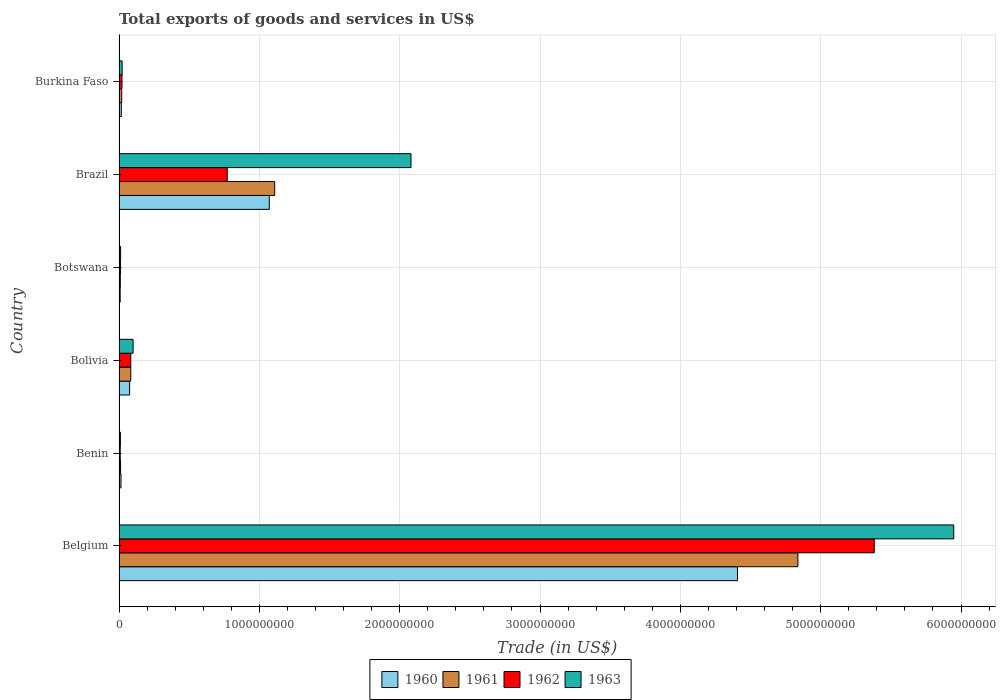Are the number of bars on each tick of the Y-axis equal?
Ensure brevity in your answer.  Yes. How many bars are there on the 1st tick from the bottom?
Your answer should be compact. 4. In how many cases, is the number of bars for a given country not equal to the number of legend labels?
Provide a short and direct response. 0. What is the total exports of goods and services in 1962 in Bolivia?
Offer a terse response. 8.35e+07. Across all countries, what is the maximum total exports of goods and services in 1962?
Offer a terse response. 5.38e+09. Across all countries, what is the minimum total exports of goods and services in 1961?
Keep it short and to the point. 8.95e+06. In which country was the total exports of goods and services in 1961 minimum?
Ensure brevity in your answer.  Botswana. What is the total total exports of goods and services in 1961 in the graph?
Your answer should be compact. 6.07e+09. What is the difference between the total exports of goods and services in 1963 in Botswana and that in Burkina Faso?
Your response must be concise. -1.09e+07. What is the difference between the total exports of goods and services in 1963 in Bolivia and the total exports of goods and services in 1960 in Benin?
Your answer should be compact. 8.63e+07. What is the average total exports of goods and services in 1961 per country?
Provide a short and direct response. 1.01e+09. What is the difference between the total exports of goods and services in 1963 and total exports of goods and services in 1961 in Burkina Faso?
Provide a succinct answer. 2.97e+06. In how many countries, is the total exports of goods and services in 1963 greater than 3800000000 US$?
Your response must be concise. 1. What is the ratio of the total exports of goods and services in 1963 in Benin to that in Botswana?
Offer a very short reply. 0.88. Is the total exports of goods and services in 1963 in Benin less than that in Bolivia?
Your response must be concise. Yes. Is the difference between the total exports of goods and services in 1963 in Benin and Botswana greater than the difference between the total exports of goods and services in 1961 in Benin and Botswana?
Ensure brevity in your answer.  No. What is the difference between the highest and the second highest total exports of goods and services in 1962?
Ensure brevity in your answer.  4.61e+09. What is the difference between the highest and the lowest total exports of goods and services in 1960?
Your answer should be very brief. 4.40e+09. In how many countries, is the total exports of goods and services in 1960 greater than the average total exports of goods and services in 1960 taken over all countries?
Provide a short and direct response. 2. Is it the case that in every country, the sum of the total exports of goods and services in 1960 and total exports of goods and services in 1961 is greater than the sum of total exports of goods and services in 1962 and total exports of goods and services in 1963?
Provide a short and direct response. No. What does the 3rd bar from the bottom in Brazil represents?
Make the answer very short. 1962. How many bars are there?
Your answer should be compact. 24. Are the values on the major ticks of X-axis written in scientific E-notation?
Provide a short and direct response. No. How are the legend labels stacked?
Ensure brevity in your answer.  Horizontal. What is the title of the graph?
Provide a short and direct response. Total exports of goods and services in US$. What is the label or title of the X-axis?
Offer a very short reply. Trade (in US$). What is the label or title of the Y-axis?
Ensure brevity in your answer.  Country. What is the Trade (in US$) in 1960 in Belgium?
Your response must be concise. 4.41e+09. What is the Trade (in US$) of 1961 in Belgium?
Offer a terse response. 4.84e+09. What is the Trade (in US$) in 1962 in Belgium?
Make the answer very short. 5.38e+09. What is the Trade (in US$) in 1963 in Belgium?
Offer a terse response. 5.95e+09. What is the Trade (in US$) of 1960 in Benin?
Your answer should be very brief. 1.39e+07. What is the Trade (in US$) in 1961 in Benin?
Your answer should be compact. 1.08e+07. What is the Trade (in US$) in 1962 in Benin?
Give a very brief answer. 8.32e+06. What is the Trade (in US$) of 1963 in Benin?
Keep it short and to the point. 9.70e+06. What is the Trade (in US$) of 1960 in Bolivia?
Your answer should be very brief. 7.51e+07. What is the Trade (in US$) of 1961 in Bolivia?
Make the answer very short. 8.35e+07. What is the Trade (in US$) of 1962 in Bolivia?
Your response must be concise. 8.35e+07. What is the Trade (in US$) in 1963 in Bolivia?
Offer a very short reply. 1.00e+08. What is the Trade (in US$) of 1960 in Botswana?
Offer a very short reply. 7.99e+06. What is the Trade (in US$) in 1961 in Botswana?
Your answer should be very brief. 8.95e+06. What is the Trade (in US$) of 1962 in Botswana?
Keep it short and to the point. 9.95e+06. What is the Trade (in US$) of 1963 in Botswana?
Your answer should be compact. 1.10e+07. What is the Trade (in US$) of 1960 in Brazil?
Give a very brief answer. 1.07e+09. What is the Trade (in US$) of 1961 in Brazil?
Provide a short and direct response. 1.11e+09. What is the Trade (in US$) in 1962 in Brazil?
Offer a terse response. 7.71e+08. What is the Trade (in US$) of 1963 in Brazil?
Provide a succinct answer. 2.08e+09. What is the Trade (in US$) in 1960 in Burkina Faso?
Keep it short and to the point. 1.61e+07. What is the Trade (in US$) in 1961 in Burkina Faso?
Make the answer very short. 1.90e+07. What is the Trade (in US$) in 1962 in Burkina Faso?
Make the answer very short. 2.10e+07. What is the Trade (in US$) in 1963 in Burkina Faso?
Keep it short and to the point. 2.20e+07. Across all countries, what is the maximum Trade (in US$) of 1960?
Your response must be concise. 4.41e+09. Across all countries, what is the maximum Trade (in US$) of 1961?
Give a very brief answer. 4.84e+09. Across all countries, what is the maximum Trade (in US$) of 1962?
Offer a terse response. 5.38e+09. Across all countries, what is the maximum Trade (in US$) of 1963?
Give a very brief answer. 5.95e+09. Across all countries, what is the minimum Trade (in US$) of 1960?
Offer a very short reply. 7.99e+06. Across all countries, what is the minimum Trade (in US$) of 1961?
Offer a very short reply. 8.95e+06. Across all countries, what is the minimum Trade (in US$) of 1962?
Keep it short and to the point. 8.32e+06. Across all countries, what is the minimum Trade (in US$) of 1963?
Your answer should be compact. 9.70e+06. What is the total Trade (in US$) of 1960 in the graph?
Provide a short and direct response. 5.59e+09. What is the total Trade (in US$) of 1961 in the graph?
Ensure brevity in your answer.  6.07e+09. What is the total Trade (in US$) in 1962 in the graph?
Make the answer very short. 6.28e+09. What is the total Trade (in US$) in 1963 in the graph?
Ensure brevity in your answer.  8.17e+09. What is the difference between the Trade (in US$) of 1960 in Belgium and that in Benin?
Provide a succinct answer. 4.39e+09. What is the difference between the Trade (in US$) of 1961 in Belgium and that in Benin?
Your answer should be compact. 4.83e+09. What is the difference between the Trade (in US$) in 1962 in Belgium and that in Benin?
Offer a very short reply. 5.37e+09. What is the difference between the Trade (in US$) of 1963 in Belgium and that in Benin?
Provide a succinct answer. 5.94e+09. What is the difference between the Trade (in US$) of 1960 in Belgium and that in Bolivia?
Make the answer very short. 4.33e+09. What is the difference between the Trade (in US$) in 1961 in Belgium and that in Bolivia?
Offer a very short reply. 4.75e+09. What is the difference between the Trade (in US$) of 1962 in Belgium and that in Bolivia?
Provide a succinct answer. 5.30e+09. What is the difference between the Trade (in US$) in 1963 in Belgium and that in Bolivia?
Offer a very short reply. 5.85e+09. What is the difference between the Trade (in US$) in 1960 in Belgium and that in Botswana?
Keep it short and to the point. 4.40e+09. What is the difference between the Trade (in US$) of 1961 in Belgium and that in Botswana?
Offer a very short reply. 4.83e+09. What is the difference between the Trade (in US$) of 1962 in Belgium and that in Botswana?
Keep it short and to the point. 5.37e+09. What is the difference between the Trade (in US$) in 1963 in Belgium and that in Botswana?
Provide a succinct answer. 5.94e+09. What is the difference between the Trade (in US$) of 1960 in Belgium and that in Brazil?
Offer a very short reply. 3.34e+09. What is the difference between the Trade (in US$) in 1961 in Belgium and that in Brazil?
Provide a succinct answer. 3.73e+09. What is the difference between the Trade (in US$) in 1962 in Belgium and that in Brazil?
Ensure brevity in your answer.  4.61e+09. What is the difference between the Trade (in US$) of 1963 in Belgium and that in Brazil?
Ensure brevity in your answer.  3.87e+09. What is the difference between the Trade (in US$) of 1960 in Belgium and that in Burkina Faso?
Make the answer very short. 4.39e+09. What is the difference between the Trade (in US$) of 1961 in Belgium and that in Burkina Faso?
Provide a succinct answer. 4.82e+09. What is the difference between the Trade (in US$) of 1962 in Belgium and that in Burkina Faso?
Offer a very short reply. 5.36e+09. What is the difference between the Trade (in US$) of 1963 in Belgium and that in Burkina Faso?
Your answer should be very brief. 5.93e+09. What is the difference between the Trade (in US$) in 1960 in Benin and that in Bolivia?
Your response must be concise. -6.13e+07. What is the difference between the Trade (in US$) in 1961 in Benin and that in Bolivia?
Offer a very short reply. -7.27e+07. What is the difference between the Trade (in US$) in 1962 in Benin and that in Bolivia?
Your answer should be compact. -7.52e+07. What is the difference between the Trade (in US$) of 1963 in Benin and that in Bolivia?
Offer a very short reply. -9.05e+07. What is the difference between the Trade (in US$) of 1960 in Benin and that in Botswana?
Make the answer very short. 5.86e+06. What is the difference between the Trade (in US$) in 1961 in Benin and that in Botswana?
Your answer should be compact. 1.85e+06. What is the difference between the Trade (in US$) in 1962 in Benin and that in Botswana?
Make the answer very short. -1.64e+06. What is the difference between the Trade (in US$) of 1963 in Benin and that in Botswana?
Your answer should be very brief. -1.34e+06. What is the difference between the Trade (in US$) of 1960 in Benin and that in Brazil?
Make the answer very short. -1.06e+09. What is the difference between the Trade (in US$) of 1961 in Benin and that in Brazil?
Give a very brief answer. -1.10e+09. What is the difference between the Trade (in US$) in 1962 in Benin and that in Brazil?
Your response must be concise. -7.63e+08. What is the difference between the Trade (in US$) in 1963 in Benin and that in Brazil?
Give a very brief answer. -2.07e+09. What is the difference between the Trade (in US$) of 1960 in Benin and that in Burkina Faso?
Keep it short and to the point. -2.21e+06. What is the difference between the Trade (in US$) in 1961 in Benin and that in Burkina Faso?
Provide a succinct answer. -8.21e+06. What is the difference between the Trade (in US$) in 1962 in Benin and that in Burkina Faso?
Make the answer very short. -1.27e+07. What is the difference between the Trade (in US$) of 1963 in Benin and that in Burkina Faso?
Your answer should be compact. -1.23e+07. What is the difference between the Trade (in US$) of 1960 in Bolivia and that in Botswana?
Provide a succinct answer. 6.71e+07. What is the difference between the Trade (in US$) of 1961 in Bolivia and that in Botswana?
Your answer should be very brief. 7.45e+07. What is the difference between the Trade (in US$) of 1962 in Bolivia and that in Botswana?
Provide a succinct answer. 7.35e+07. What is the difference between the Trade (in US$) of 1963 in Bolivia and that in Botswana?
Provide a short and direct response. 8.91e+07. What is the difference between the Trade (in US$) in 1960 in Bolivia and that in Brazil?
Give a very brief answer. -9.95e+08. What is the difference between the Trade (in US$) of 1961 in Bolivia and that in Brazil?
Your response must be concise. -1.03e+09. What is the difference between the Trade (in US$) of 1962 in Bolivia and that in Brazil?
Your response must be concise. -6.87e+08. What is the difference between the Trade (in US$) in 1963 in Bolivia and that in Brazil?
Your answer should be very brief. -1.98e+09. What is the difference between the Trade (in US$) of 1960 in Bolivia and that in Burkina Faso?
Provide a succinct answer. 5.91e+07. What is the difference between the Trade (in US$) of 1961 in Bolivia and that in Burkina Faso?
Provide a short and direct response. 6.45e+07. What is the difference between the Trade (in US$) in 1962 in Bolivia and that in Burkina Faso?
Provide a succinct answer. 6.25e+07. What is the difference between the Trade (in US$) of 1963 in Bolivia and that in Burkina Faso?
Your answer should be compact. 7.82e+07. What is the difference between the Trade (in US$) in 1960 in Botswana and that in Brazil?
Offer a terse response. -1.06e+09. What is the difference between the Trade (in US$) in 1961 in Botswana and that in Brazil?
Provide a short and direct response. -1.10e+09. What is the difference between the Trade (in US$) of 1962 in Botswana and that in Brazil?
Provide a succinct answer. -7.61e+08. What is the difference between the Trade (in US$) of 1963 in Botswana and that in Brazil?
Keep it short and to the point. -2.07e+09. What is the difference between the Trade (in US$) of 1960 in Botswana and that in Burkina Faso?
Offer a terse response. -8.08e+06. What is the difference between the Trade (in US$) in 1961 in Botswana and that in Burkina Faso?
Your response must be concise. -1.01e+07. What is the difference between the Trade (in US$) of 1962 in Botswana and that in Burkina Faso?
Offer a terse response. -1.10e+07. What is the difference between the Trade (in US$) of 1963 in Botswana and that in Burkina Faso?
Give a very brief answer. -1.09e+07. What is the difference between the Trade (in US$) in 1960 in Brazil and that in Burkina Faso?
Keep it short and to the point. 1.05e+09. What is the difference between the Trade (in US$) of 1961 in Brazil and that in Burkina Faso?
Provide a short and direct response. 1.09e+09. What is the difference between the Trade (in US$) of 1962 in Brazil and that in Burkina Faso?
Make the answer very short. 7.50e+08. What is the difference between the Trade (in US$) in 1963 in Brazil and that in Burkina Faso?
Your answer should be compact. 2.06e+09. What is the difference between the Trade (in US$) in 1960 in Belgium and the Trade (in US$) in 1961 in Benin?
Offer a terse response. 4.40e+09. What is the difference between the Trade (in US$) in 1960 in Belgium and the Trade (in US$) in 1962 in Benin?
Offer a terse response. 4.40e+09. What is the difference between the Trade (in US$) in 1960 in Belgium and the Trade (in US$) in 1963 in Benin?
Offer a very short reply. 4.40e+09. What is the difference between the Trade (in US$) of 1961 in Belgium and the Trade (in US$) of 1962 in Benin?
Offer a very short reply. 4.83e+09. What is the difference between the Trade (in US$) in 1961 in Belgium and the Trade (in US$) in 1963 in Benin?
Your answer should be very brief. 4.83e+09. What is the difference between the Trade (in US$) in 1962 in Belgium and the Trade (in US$) in 1963 in Benin?
Offer a very short reply. 5.37e+09. What is the difference between the Trade (in US$) of 1960 in Belgium and the Trade (in US$) of 1961 in Bolivia?
Make the answer very short. 4.32e+09. What is the difference between the Trade (in US$) in 1960 in Belgium and the Trade (in US$) in 1962 in Bolivia?
Your answer should be very brief. 4.32e+09. What is the difference between the Trade (in US$) in 1960 in Belgium and the Trade (in US$) in 1963 in Bolivia?
Your response must be concise. 4.31e+09. What is the difference between the Trade (in US$) in 1961 in Belgium and the Trade (in US$) in 1962 in Bolivia?
Make the answer very short. 4.75e+09. What is the difference between the Trade (in US$) of 1961 in Belgium and the Trade (in US$) of 1963 in Bolivia?
Provide a succinct answer. 4.74e+09. What is the difference between the Trade (in US$) of 1962 in Belgium and the Trade (in US$) of 1963 in Bolivia?
Offer a terse response. 5.28e+09. What is the difference between the Trade (in US$) in 1960 in Belgium and the Trade (in US$) in 1961 in Botswana?
Your answer should be compact. 4.40e+09. What is the difference between the Trade (in US$) of 1960 in Belgium and the Trade (in US$) of 1962 in Botswana?
Keep it short and to the point. 4.40e+09. What is the difference between the Trade (in US$) of 1960 in Belgium and the Trade (in US$) of 1963 in Botswana?
Offer a very short reply. 4.40e+09. What is the difference between the Trade (in US$) of 1961 in Belgium and the Trade (in US$) of 1962 in Botswana?
Your response must be concise. 4.83e+09. What is the difference between the Trade (in US$) of 1961 in Belgium and the Trade (in US$) of 1963 in Botswana?
Offer a very short reply. 4.83e+09. What is the difference between the Trade (in US$) of 1962 in Belgium and the Trade (in US$) of 1963 in Botswana?
Make the answer very short. 5.37e+09. What is the difference between the Trade (in US$) of 1960 in Belgium and the Trade (in US$) of 1961 in Brazil?
Offer a very short reply. 3.30e+09. What is the difference between the Trade (in US$) of 1960 in Belgium and the Trade (in US$) of 1962 in Brazil?
Offer a terse response. 3.64e+09. What is the difference between the Trade (in US$) of 1960 in Belgium and the Trade (in US$) of 1963 in Brazil?
Offer a terse response. 2.33e+09. What is the difference between the Trade (in US$) in 1961 in Belgium and the Trade (in US$) in 1962 in Brazil?
Ensure brevity in your answer.  4.07e+09. What is the difference between the Trade (in US$) in 1961 in Belgium and the Trade (in US$) in 1963 in Brazil?
Your answer should be compact. 2.76e+09. What is the difference between the Trade (in US$) of 1962 in Belgium and the Trade (in US$) of 1963 in Brazil?
Ensure brevity in your answer.  3.30e+09. What is the difference between the Trade (in US$) of 1960 in Belgium and the Trade (in US$) of 1961 in Burkina Faso?
Give a very brief answer. 4.39e+09. What is the difference between the Trade (in US$) in 1960 in Belgium and the Trade (in US$) in 1962 in Burkina Faso?
Provide a short and direct response. 4.39e+09. What is the difference between the Trade (in US$) of 1960 in Belgium and the Trade (in US$) of 1963 in Burkina Faso?
Offer a very short reply. 4.39e+09. What is the difference between the Trade (in US$) in 1961 in Belgium and the Trade (in US$) in 1962 in Burkina Faso?
Your response must be concise. 4.82e+09. What is the difference between the Trade (in US$) of 1961 in Belgium and the Trade (in US$) of 1963 in Burkina Faso?
Keep it short and to the point. 4.82e+09. What is the difference between the Trade (in US$) of 1962 in Belgium and the Trade (in US$) of 1963 in Burkina Faso?
Provide a short and direct response. 5.36e+09. What is the difference between the Trade (in US$) in 1960 in Benin and the Trade (in US$) in 1961 in Bolivia?
Your answer should be very brief. -6.96e+07. What is the difference between the Trade (in US$) of 1960 in Benin and the Trade (in US$) of 1962 in Bolivia?
Your response must be concise. -6.96e+07. What is the difference between the Trade (in US$) of 1960 in Benin and the Trade (in US$) of 1963 in Bolivia?
Provide a short and direct response. -8.63e+07. What is the difference between the Trade (in US$) of 1961 in Benin and the Trade (in US$) of 1962 in Bolivia?
Make the answer very short. -7.27e+07. What is the difference between the Trade (in US$) in 1961 in Benin and the Trade (in US$) in 1963 in Bolivia?
Keep it short and to the point. -8.94e+07. What is the difference between the Trade (in US$) in 1962 in Benin and the Trade (in US$) in 1963 in Bolivia?
Offer a very short reply. -9.19e+07. What is the difference between the Trade (in US$) of 1960 in Benin and the Trade (in US$) of 1961 in Botswana?
Provide a short and direct response. 4.90e+06. What is the difference between the Trade (in US$) of 1960 in Benin and the Trade (in US$) of 1962 in Botswana?
Keep it short and to the point. 3.90e+06. What is the difference between the Trade (in US$) of 1960 in Benin and the Trade (in US$) of 1963 in Botswana?
Keep it short and to the point. 2.81e+06. What is the difference between the Trade (in US$) of 1961 in Benin and the Trade (in US$) of 1962 in Botswana?
Offer a very short reply. 8.48e+05. What is the difference between the Trade (in US$) in 1961 in Benin and the Trade (in US$) in 1963 in Botswana?
Make the answer very short. -2.43e+05. What is the difference between the Trade (in US$) of 1962 in Benin and the Trade (in US$) of 1963 in Botswana?
Keep it short and to the point. -2.73e+06. What is the difference between the Trade (in US$) in 1960 in Benin and the Trade (in US$) in 1961 in Brazil?
Offer a very short reply. -1.10e+09. What is the difference between the Trade (in US$) of 1960 in Benin and the Trade (in US$) of 1962 in Brazil?
Provide a succinct answer. -7.57e+08. What is the difference between the Trade (in US$) of 1960 in Benin and the Trade (in US$) of 1963 in Brazil?
Provide a succinct answer. -2.07e+09. What is the difference between the Trade (in US$) in 1961 in Benin and the Trade (in US$) in 1962 in Brazil?
Your answer should be compact. -7.60e+08. What is the difference between the Trade (in US$) of 1961 in Benin and the Trade (in US$) of 1963 in Brazil?
Ensure brevity in your answer.  -2.07e+09. What is the difference between the Trade (in US$) in 1962 in Benin and the Trade (in US$) in 1963 in Brazil?
Make the answer very short. -2.07e+09. What is the difference between the Trade (in US$) of 1960 in Benin and the Trade (in US$) of 1961 in Burkina Faso?
Your answer should be very brief. -5.16e+06. What is the difference between the Trade (in US$) of 1960 in Benin and the Trade (in US$) of 1962 in Burkina Faso?
Your response must be concise. -7.15e+06. What is the difference between the Trade (in US$) in 1960 in Benin and the Trade (in US$) in 1963 in Burkina Faso?
Provide a short and direct response. -8.13e+06. What is the difference between the Trade (in US$) in 1961 in Benin and the Trade (in US$) in 1962 in Burkina Faso?
Keep it short and to the point. -1.02e+07. What is the difference between the Trade (in US$) of 1961 in Benin and the Trade (in US$) of 1963 in Burkina Faso?
Offer a very short reply. -1.12e+07. What is the difference between the Trade (in US$) in 1962 in Benin and the Trade (in US$) in 1963 in Burkina Faso?
Keep it short and to the point. -1.37e+07. What is the difference between the Trade (in US$) of 1960 in Bolivia and the Trade (in US$) of 1961 in Botswana?
Your answer should be compact. 6.62e+07. What is the difference between the Trade (in US$) in 1960 in Bolivia and the Trade (in US$) in 1962 in Botswana?
Your answer should be compact. 6.52e+07. What is the difference between the Trade (in US$) in 1960 in Bolivia and the Trade (in US$) in 1963 in Botswana?
Offer a very short reply. 6.41e+07. What is the difference between the Trade (in US$) of 1961 in Bolivia and the Trade (in US$) of 1962 in Botswana?
Offer a terse response. 7.35e+07. What is the difference between the Trade (in US$) of 1961 in Bolivia and the Trade (in US$) of 1963 in Botswana?
Offer a terse response. 7.24e+07. What is the difference between the Trade (in US$) of 1962 in Bolivia and the Trade (in US$) of 1963 in Botswana?
Your answer should be very brief. 7.24e+07. What is the difference between the Trade (in US$) in 1960 in Bolivia and the Trade (in US$) in 1961 in Brazil?
Make the answer very short. -1.03e+09. What is the difference between the Trade (in US$) in 1960 in Bolivia and the Trade (in US$) in 1962 in Brazil?
Provide a succinct answer. -6.96e+08. What is the difference between the Trade (in US$) of 1960 in Bolivia and the Trade (in US$) of 1963 in Brazil?
Keep it short and to the point. -2.01e+09. What is the difference between the Trade (in US$) of 1961 in Bolivia and the Trade (in US$) of 1962 in Brazil?
Provide a succinct answer. -6.87e+08. What is the difference between the Trade (in US$) of 1961 in Bolivia and the Trade (in US$) of 1963 in Brazil?
Your response must be concise. -2.00e+09. What is the difference between the Trade (in US$) in 1962 in Bolivia and the Trade (in US$) in 1963 in Brazil?
Give a very brief answer. -2.00e+09. What is the difference between the Trade (in US$) in 1960 in Bolivia and the Trade (in US$) in 1961 in Burkina Faso?
Provide a succinct answer. 5.61e+07. What is the difference between the Trade (in US$) of 1960 in Bolivia and the Trade (in US$) of 1962 in Burkina Faso?
Provide a short and direct response. 5.41e+07. What is the difference between the Trade (in US$) in 1960 in Bolivia and the Trade (in US$) in 1963 in Burkina Faso?
Your answer should be compact. 5.31e+07. What is the difference between the Trade (in US$) of 1961 in Bolivia and the Trade (in US$) of 1962 in Burkina Faso?
Offer a very short reply. 6.25e+07. What is the difference between the Trade (in US$) of 1961 in Bolivia and the Trade (in US$) of 1963 in Burkina Faso?
Ensure brevity in your answer.  6.15e+07. What is the difference between the Trade (in US$) in 1962 in Bolivia and the Trade (in US$) in 1963 in Burkina Faso?
Your answer should be very brief. 6.15e+07. What is the difference between the Trade (in US$) in 1960 in Botswana and the Trade (in US$) in 1961 in Brazil?
Your response must be concise. -1.10e+09. What is the difference between the Trade (in US$) in 1960 in Botswana and the Trade (in US$) in 1962 in Brazil?
Your answer should be compact. -7.63e+08. What is the difference between the Trade (in US$) of 1960 in Botswana and the Trade (in US$) of 1963 in Brazil?
Offer a terse response. -2.07e+09. What is the difference between the Trade (in US$) in 1961 in Botswana and the Trade (in US$) in 1962 in Brazil?
Offer a terse response. -7.62e+08. What is the difference between the Trade (in US$) in 1961 in Botswana and the Trade (in US$) in 1963 in Brazil?
Make the answer very short. -2.07e+09. What is the difference between the Trade (in US$) in 1962 in Botswana and the Trade (in US$) in 1963 in Brazil?
Offer a terse response. -2.07e+09. What is the difference between the Trade (in US$) of 1960 in Botswana and the Trade (in US$) of 1961 in Burkina Faso?
Offer a very short reply. -1.10e+07. What is the difference between the Trade (in US$) of 1960 in Botswana and the Trade (in US$) of 1962 in Burkina Faso?
Your answer should be very brief. -1.30e+07. What is the difference between the Trade (in US$) in 1960 in Botswana and the Trade (in US$) in 1963 in Burkina Faso?
Provide a succinct answer. -1.40e+07. What is the difference between the Trade (in US$) in 1961 in Botswana and the Trade (in US$) in 1962 in Burkina Faso?
Provide a succinct answer. -1.20e+07. What is the difference between the Trade (in US$) in 1961 in Botswana and the Trade (in US$) in 1963 in Burkina Faso?
Keep it short and to the point. -1.30e+07. What is the difference between the Trade (in US$) of 1962 in Botswana and the Trade (in US$) of 1963 in Burkina Faso?
Ensure brevity in your answer.  -1.20e+07. What is the difference between the Trade (in US$) of 1960 in Brazil and the Trade (in US$) of 1961 in Burkina Faso?
Offer a terse response. 1.05e+09. What is the difference between the Trade (in US$) of 1960 in Brazil and the Trade (in US$) of 1962 in Burkina Faso?
Your answer should be very brief. 1.05e+09. What is the difference between the Trade (in US$) of 1960 in Brazil and the Trade (in US$) of 1963 in Burkina Faso?
Ensure brevity in your answer.  1.05e+09. What is the difference between the Trade (in US$) in 1961 in Brazil and the Trade (in US$) in 1962 in Burkina Faso?
Keep it short and to the point. 1.09e+09. What is the difference between the Trade (in US$) of 1961 in Brazil and the Trade (in US$) of 1963 in Burkina Faso?
Make the answer very short. 1.09e+09. What is the difference between the Trade (in US$) of 1962 in Brazil and the Trade (in US$) of 1963 in Burkina Faso?
Your answer should be very brief. 7.49e+08. What is the average Trade (in US$) of 1960 per country?
Offer a very short reply. 9.32e+08. What is the average Trade (in US$) in 1961 per country?
Your response must be concise. 1.01e+09. What is the average Trade (in US$) in 1962 per country?
Offer a very short reply. 1.05e+09. What is the average Trade (in US$) in 1963 per country?
Offer a very short reply. 1.36e+09. What is the difference between the Trade (in US$) of 1960 and Trade (in US$) of 1961 in Belgium?
Offer a very short reply. -4.31e+08. What is the difference between the Trade (in US$) of 1960 and Trade (in US$) of 1962 in Belgium?
Give a very brief answer. -9.75e+08. What is the difference between the Trade (in US$) of 1960 and Trade (in US$) of 1963 in Belgium?
Your answer should be compact. -1.54e+09. What is the difference between the Trade (in US$) in 1961 and Trade (in US$) in 1962 in Belgium?
Ensure brevity in your answer.  -5.44e+08. What is the difference between the Trade (in US$) of 1961 and Trade (in US$) of 1963 in Belgium?
Make the answer very short. -1.11e+09. What is the difference between the Trade (in US$) of 1962 and Trade (in US$) of 1963 in Belgium?
Make the answer very short. -5.67e+08. What is the difference between the Trade (in US$) of 1960 and Trade (in US$) of 1961 in Benin?
Keep it short and to the point. 3.05e+06. What is the difference between the Trade (in US$) of 1960 and Trade (in US$) of 1962 in Benin?
Your answer should be very brief. 5.53e+06. What is the difference between the Trade (in US$) in 1960 and Trade (in US$) in 1963 in Benin?
Provide a short and direct response. 4.15e+06. What is the difference between the Trade (in US$) in 1961 and Trade (in US$) in 1962 in Benin?
Make the answer very short. 2.48e+06. What is the difference between the Trade (in US$) in 1961 and Trade (in US$) in 1963 in Benin?
Give a very brief answer. 1.10e+06. What is the difference between the Trade (in US$) in 1962 and Trade (in US$) in 1963 in Benin?
Keep it short and to the point. -1.39e+06. What is the difference between the Trade (in US$) in 1960 and Trade (in US$) in 1961 in Bolivia?
Keep it short and to the point. -8.35e+06. What is the difference between the Trade (in US$) in 1960 and Trade (in US$) in 1962 in Bolivia?
Your response must be concise. -8.35e+06. What is the difference between the Trade (in US$) in 1960 and Trade (in US$) in 1963 in Bolivia?
Your response must be concise. -2.50e+07. What is the difference between the Trade (in US$) in 1961 and Trade (in US$) in 1963 in Bolivia?
Your answer should be compact. -1.67e+07. What is the difference between the Trade (in US$) in 1962 and Trade (in US$) in 1963 in Bolivia?
Your answer should be very brief. -1.67e+07. What is the difference between the Trade (in US$) in 1960 and Trade (in US$) in 1961 in Botswana?
Make the answer very short. -9.64e+05. What is the difference between the Trade (in US$) of 1960 and Trade (in US$) of 1962 in Botswana?
Offer a very short reply. -1.96e+06. What is the difference between the Trade (in US$) of 1960 and Trade (in US$) of 1963 in Botswana?
Offer a very short reply. -3.05e+06. What is the difference between the Trade (in US$) in 1961 and Trade (in US$) in 1962 in Botswana?
Your response must be concise. -9.99e+05. What is the difference between the Trade (in US$) of 1961 and Trade (in US$) of 1963 in Botswana?
Your answer should be compact. -2.09e+06. What is the difference between the Trade (in US$) of 1962 and Trade (in US$) of 1963 in Botswana?
Keep it short and to the point. -1.09e+06. What is the difference between the Trade (in US$) of 1960 and Trade (in US$) of 1961 in Brazil?
Keep it short and to the point. -3.86e+07. What is the difference between the Trade (in US$) in 1960 and Trade (in US$) in 1962 in Brazil?
Give a very brief answer. 3.00e+08. What is the difference between the Trade (in US$) of 1960 and Trade (in US$) of 1963 in Brazil?
Offer a very short reply. -1.01e+09. What is the difference between the Trade (in US$) in 1961 and Trade (in US$) in 1962 in Brazil?
Offer a very short reply. 3.38e+08. What is the difference between the Trade (in US$) of 1961 and Trade (in US$) of 1963 in Brazil?
Give a very brief answer. -9.71e+08. What is the difference between the Trade (in US$) of 1962 and Trade (in US$) of 1963 in Brazil?
Your answer should be very brief. -1.31e+09. What is the difference between the Trade (in US$) of 1960 and Trade (in US$) of 1961 in Burkina Faso?
Provide a short and direct response. -2.95e+06. What is the difference between the Trade (in US$) of 1960 and Trade (in US$) of 1962 in Burkina Faso?
Your answer should be compact. -4.93e+06. What is the difference between the Trade (in US$) in 1960 and Trade (in US$) in 1963 in Burkina Faso?
Provide a short and direct response. -5.92e+06. What is the difference between the Trade (in US$) of 1961 and Trade (in US$) of 1962 in Burkina Faso?
Provide a succinct answer. -1.98e+06. What is the difference between the Trade (in US$) of 1961 and Trade (in US$) of 1963 in Burkina Faso?
Offer a terse response. -2.97e+06. What is the difference between the Trade (in US$) in 1962 and Trade (in US$) in 1963 in Burkina Faso?
Your response must be concise. -9.88e+05. What is the ratio of the Trade (in US$) in 1960 in Belgium to that in Benin?
Give a very brief answer. 318.15. What is the ratio of the Trade (in US$) in 1961 in Belgium to that in Benin?
Your answer should be very brief. 447.86. What is the ratio of the Trade (in US$) in 1962 in Belgium to that in Benin?
Offer a very short reply. 647.03. What is the ratio of the Trade (in US$) of 1963 in Belgium to that in Benin?
Ensure brevity in your answer.  613. What is the ratio of the Trade (in US$) in 1960 in Belgium to that in Bolivia?
Provide a short and direct response. 58.66. What is the ratio of the Trade (in US$) of 1961 in Belgium to that in Bolivia?
Your answer should be very brief. 57.95. What is the ratio of the Trade (in US$) in 1962 in Belgium to that in Bolivia?
Give a very brief answer. 64.47. What is the ratio of the Trade (in US$) in 1963 in Belgium to that in Bolivia?
Make the answer very short. 59.38. What is the ratio of the Trade (in US$) of 1960 in Belgium to that in Botswana?
Provide a succinct answer. 551.52. What is the ratio of the Trade (in US$) of 1961 in Belgium to that in Botswana?
Offer a very short reply. 540.23. What is the ratio of the Trade (in US$) in 1962 in Belgium to that in Botswana?
Your answer should be very brief. 540.64. What is the ratio of the Trade (in US$) of 1963 in Belgium to that in Botswana?
Your response must be concise. 538.57. What is the ratio of the Trade (in US$) in 1960 in Belgium to that in Brazil?
Give a very brief answer. 4.12. What is the ratio of the Trade (in US$) of 1961 in Belgium to that in Brazil?
Your answer should be very brief. 4.36. What is the ratio of the Trade (in US$) of 1962 in Belgium to that in Brazil?
Make the answer very short. 6.98. What is the ratio of the Trade (in US$) of 1963 in Belgium to that in Brazil?
Keep it short and to the point. 2.86. What is the ratio of the Trade (in US$) of 1960 in Belgium to that in Burkina Faso?
Your answer should be very brief. 274.31. What is the ratio of the Trade (in US$) of 1961 in Belgium to that in Burkina Faso?
Offer a terse response. 254.42. What is the ratio of the Trade (in US$) in 1962 in Belgium to that in Burkina Faso?
Offer a terse response. 256.3. What is the ratio of the Trade (in US$) of 1963 in Belgium to that in Burkina Faso?
Provide a short and direct response. 270.55. What is the ratio of the Trade (in US$) in 1960 in Benin to that in Bolivia?
Provide a succinct answer. 0.18. What is the ratio of the Trade (in US$) in 1961 in Benin to that in Bolivia?
Offer a very short reply. 0.13. What is the ratio of the Trade (in US$) in 1962 in Benin to that in Bolivia?
Your answer should be very brief. 0.1. What is the ratio of the Trade (in US$) of 1963 in Benin to that in Bolivia?
Make the answer very short. 0.1. What is the ratio of the Trade (in US$) in 1960 in Benin to that in Botswana?
Your answer should be very brief. 1.73. What is the ratio of the Trade (in US$) of 1961 in Benin to that in Botswana?
Offer a terse response. 1.21. What is the ratio of the Trade (in US$) in 1962 in Benin to that in Botswana?
Provide a short and direct response. 0.84. What is the ratio of the Trade (in US$) in 1963 in Benin to that in Botswana?
Provide a succinct answer. 0.88. What is the ratio of the Trade (in US$) in 1960 in Benin to that in Brazil?
Provide a short and direct response. 0.01. What is the ratio of the Trade (in US$) of 1961 in Benin to that in Brazil?
Keep it short and to the point. 0.01. What is the ratio of the Trade (in US$) of 1962 in Benin to that in Brazil?
Your response must be concise. 0.01. What is the ratio of the Trade (in US$) in 1963 in Benin to that in Brazil?
Your response must be concise. 0. What is the ratio of the Trade (in US$) in 1960 in Benin to that in Burkina Faso?
Provide a short and direct response. 0.86. What is the ratio of the Trade (in US$) in 1961 in Benin to that in Burkina Faso?
Keep it short and to the point. 0.57. What is the ratio of the Trade (in US$) of 1962 in Benin to that in Burkina Faso?
Make the answer very short. 0.4. What is the ratio of the Trade (in US$) of 1963 in Benin to that in Burkina Faso?
Offer a very short reply. 0.44. What is the ratio of the Trade (in US$) in 1960 in Bolivia to that in Botswana?
Offer a very short reply. 9.4. What is the ratio of the Trade (in US$) of 1961 in Bolivia to that in Botswana?
Offer a terse response. 9.32. What is the ratio of the Trade (in US$) in 1962 in Bolivia to that in Botswana?
Give a very brief answer. 8.39. What is the ratio of the Trade (in US$) in 1963 in Bolivia to that in Botswana?
Your answer should be very brief. 9.07. What is the ratio of the Trade (in US$) in 1960 in Bolivia to that in Brazil?
Ensure brevity in your answer.  0.07. What is the ratio of the Trade (in US$) of 1961 in Bolivia to that in Brazil?
Your answer should be compact. 0.08. What is the ratio of the Trade (in US$) in 1962 in Bolivia to that in Brazil?
Offer a terse response. 0.11. What is the ratio of the Trade (in US$) in 1963 in Bolivia to that in Brazil?
Offer a terse response. 0.05. What is the ratio of the Trade (in US$) in 1960 in Bolivia to that in Burkina Faso?
Offer a terse response. 4.68. What is the ratio of the Trade (in US$) in 1961 in Bolivia to that in Burkina Faso?
Your answer should be very brief. 4.39. What is the ratio of the Trade (in US$) in 1962 in Bolivia to that in Burkina Faso?
Give a very brief answer. 3.98. What is the ratio of the Trade (in US$) of 1963 in Bolivia to that in Burkina Faso?
Provide a short and direct response. 4.56. What is the ratio of the Trade (in US$) in 1960 in Botswana to that in Brazil?
Your answer should be very brief. 0.01. What is the ratio of the Trade (in US$) in 1961 in Botswana to that in Brazil?
Make the answer very short. 0.01. What is the ratio of the Trade (in US$) of 1962 in Botswana to that in Brazil?
Ensure brevity in your answer.  0.01. What is the ratio of the Trade (in US$) in 1963 in Botswana to that in Brazil?
Give a very brief answer. 0.01. What is the ratio of the Trade (in US$) in 1960 in Botswana to that in Burkina Faso?
Your answer should be very brief. 0.5. What is the ratio of the Trade (in US$) of 1961 in Botswana to that in Burkina Faso?
Your answer should be compact. 0.47. What is the ratio of the Trade (in US$) in 1962 in Botswana to that in Burkina Faso?
Your answer should be very brief. 0.47. What is the ratio of the Trade (in US$) in 1963 in Botswana to that in Burkina Faso?
Your response must be concise. 0.5. What is the ratio of the Trade (in US$) of 1960 in Brazil to that in Burkina Faso?
Ensure brevity in your answer.  66.63. What is the ratio of the Trade (in US$) of 1961 in Brazil to that in Burkina Faso?
Your answer should be very brief. 58.33. What is the ratio of the Trade (in US$) in 1962 in Brazil to that in Burkina Faso?
Ensure brevity in your answer.  36.71. What is the ratio of the Trade (in US$) in 1963 in Brazil to that in Burkina Faso?
Give a very brief answer. 94.62. What is the difference between the highest and the second highest Trade (in US$) in 1960?
Give a very brief answer. 3.34e+09. What is the difference between the highest and the second highest Trade (in US$) in 1961?
Your response must be concise. 3.73e+09. What is the difference between the highest and the second highest Trade (in US$) of 1962?
Give a very brief answer. 4.61e+09. What is the difference between the highest and the second highest Trade (in US$) in 1963?
Make the answer very short. 3.87e+09. What is the difference between the highest and the lowest Trade (in US$) in 1960?
Keep it short and to the point. 4.40e+09. What is the difference between the highest and the lowest Trade (in US$) of 1961?
Give a very brief answer. 4.83e+09. What is the difference between the highest and the lowest Trade (in US$) of 1962?
Offer a very short reply. 5.37e+09. What is the difference between the highest and the lowest Trade (in US$) of 1963?
Offer a terse response. 5.94e+09. 